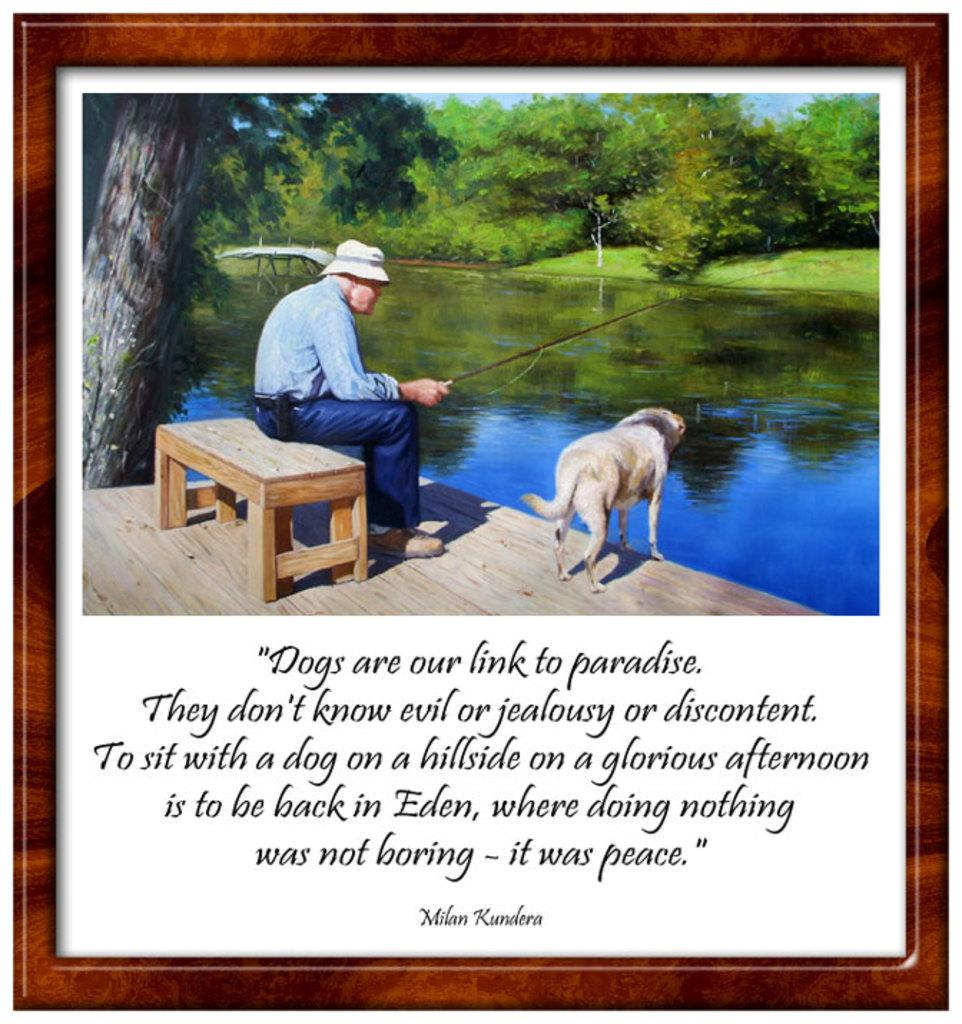<image>
Provide a brief description of the given image. A Milan Kundera quote is written under a picture of a man fishing with his dog. 